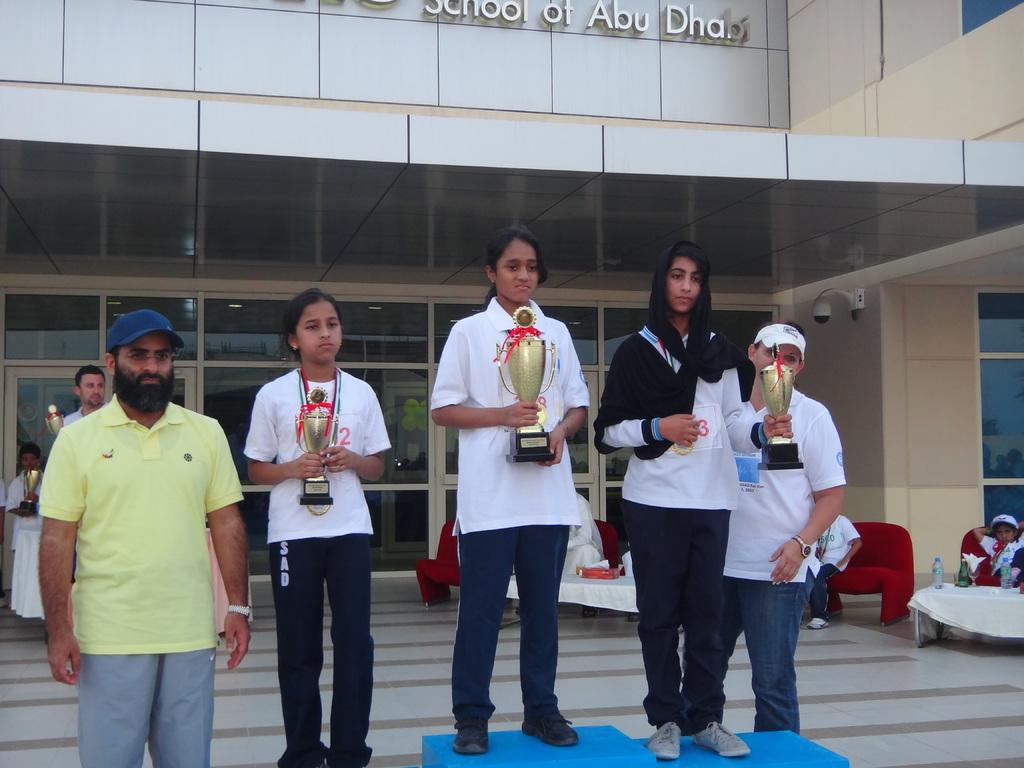How many girls are in the image? There are three girls in the image. What are the girls holding in the image? The girls are holding awards in the image. Can you describe the other people in the image? The other people in the image are resting. Where are the resting people located in the image? The resting people are on the right side of the image. What can be seen in the background of the image? There is a building in the background of the image. What type of zinc is being used by the porter in the image? There is no porter or zinc present in the image. How many dogs are visible in the image? There are no dogs present in the image. 